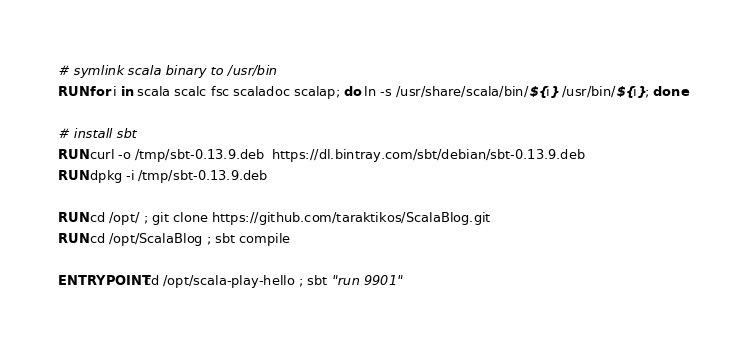<code> <loc_0><loc_0><loc_500><loc_500><_Dockerfile_>
# symlink scala binary to /usr/bin
RUN for i in scala scalc fsc scaladoc scalap; do ln -s /usr/share/scala/bin/${i} /usr/bin/${i}; done

# install sbt
RUN curl -o /tmp/sbt-0.13.9.deb  https://dl.bintray.com/sbt/debian/sbt-0.13.9.deb
RUN dpkg -i /tmp/sbt-0.13.9.deb

RUN cd /opt/ ; git clone https://github.com/taraktikos/ScalaBlog.git
RUN cd /opt/ScalaBlog ; sbt compile

ENTRYPOINT cd /opt/scala-play-hello ; sbt "run 9901"
</code> 